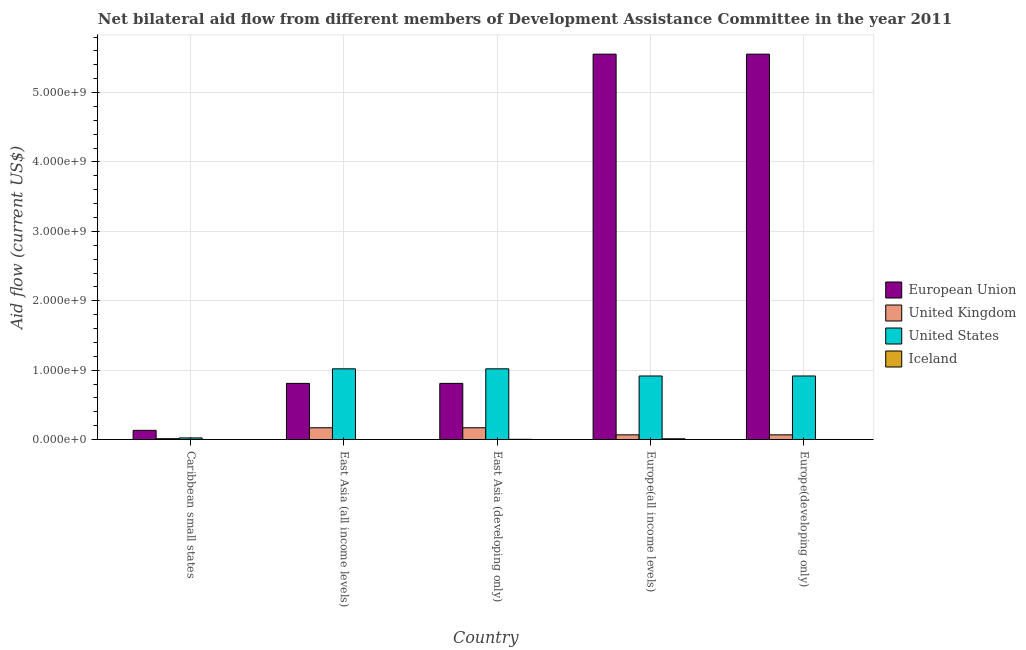How many different coloured bars are there?
Make the answer very short. 4. Are the number of bars per tick equal to the number of legend labels?
Offer a very short reply. Yes. How many bars are there on the 4th tick from the right?
Provide a succinct answer. 4. What is the label of the 3rd group of bars from the left?
Provide a succinct answer. East Asia (developing only). What is the amount of aid given by uk in Europe(developing only)?
Keep it short and to the point. 6.74e+07. Across all countries, what is the maximum amount of aid given by us?
Give a very brief answer. 1.02e+09. Across all countries, what is the minimum amount of aid given by iceland?
Your answer should be compact. 2.00e+04. In which country was the amount of aid given by us maximum?
Make the answer very short. East Asia (all income levels). In which country was the amount of aid given by uk minimum?
Keep it short and to the point. Caribbean small states. What is the total amount of aid given by iceland in the graph?
Offer a very short reply. 1.42e+07. What is the difference between the amount of aid given by iceland in Caribbean small states and that in East Asia (all income levels)?
Your response must be concise. 0. What is the difference between the amount of aid given by eu in East Asia (all income levels) and the amount of aid given by uk in Europe(developing only)?
Ensure brevity in your answer.  7.42e+08. What is the average amount of aid given by us per country?
Keep it short and to the point. 7.79e+08. What is the difference between the amount of aid given by eu and amount of aid given by us in Europe(all income levels)?
Ensure brevity in your answer.  4.64e+09. What is the ratio of the amount of aid given by eu in East Asia (all income levels) to that in Europe(developing only)?
Keep it short and to the point. 0.15. What is the difference between the highest and the second highest amount of aid given by eu?
Give a very brief answer. 0. What is the difference between the highest and the lowest amount of aid given by iceland?
Your response must be concise. 1.06e+07. In how many countries, is the amount of aid given by uk greater than the average amount of aid given by uk taken over all countries?
Keep it short and to the point. 2. Is it the case that in every country, the sum of the amount of aid given by iceland and amount of aid given by eu is greater than the sum of amount of aid given by uk and amount of aid given by us?
Ensure brevity in your answer.  Yes. Is it the case that in every country, the sum of the amount of aid given by eu and amount of aid given by uk is greater than the amount of aid given by us?
Your answer should be compact. No. What is the difference between two consecutive major ticks on the Y-axis?
Your answer should be very brief. 1.00e+09. Are the values on the major ticks of Y-axis written in scientific E-notation?
Offer a very short reply. Yes. Does the graph contain any zero values?
Keep it short and to the point. No. Where does the legend appear in the graph?
Give a very brief answer. Center right. How many legend labels are there?
Your answer should be very brief. 4. How are the legend labels stacked?
Make the answer very short. Vertical. What is the title of the graph?
Your response must be concise. Net bilateral aid flow from different members of Development Assistance Committee in the year 2011. What is the label or title of the X-axis?
Provide a succinct answer. Country. What is the Aid flow (current US$) in European Union in Caribbean small states?
Give a very brief answer. 1.32e+08. What is the Aid flow (current US$) in United Kingdom in Caribbean small states?
Give a very brief answer. 1.19e+07. What is the Aid flow (current US$) in United States in Caribbean small states?
Keep it short and to the point. 2.31e+07. What is the Aid flow (current US$) of European Union in East Asia (all income levels)?
Make the answer very short. 8.09e+08. What is the Aid flow (current US$) of United Kingdom in East Asia (all income levels)?
Your answer should be very brief. 1.69e+08. What is the Aid flow (current US$) in United States in East Asia (all income levels)?
Your response must be concise. 1.02e+09. What is the Aid flow (current US$) of Iceland in East Asia (all income levels)?
Your response must be concise. 2.00e+04. What is the Aid flow (current US$) in European Union in East Asia (developing only)?
Give a very brief answer. 8.09e+08. What is the Aid flow (current US$) of United Kingdom in East Asia (developing only)?
Your response must be concise. 1.69e+08. What is the Aid flow (current US$) in United States in East Asia (developing only)?
Make the answer very short. 1.02e+09. What is the Aid flow (current US$) in Iceland in East Asia (developing only)?
Your answer should be very brief. 2.81e+06. What is the Aid flow (current US$) in European Union in Europe(all income levels)?
Your answer should be very brief. 5.55e+09. What is the Aid flow (current US$) of United Kingdom in Europe(all income levels)?
Keep it short and to the point. 6.74e+07. What is the Aid flow (current US$) in United States in Europe(all income levels)?
Make the answer very short. 9.16e+08. What is the Aid flow (current US$) of Iceland in Europe(all income levels)?
Your answer should be compact. 1.06e+07. What is the Aid flow (current US$) in European Union in Europe(developing only)?
Your answer should be very brief. 5.55e+09. What is the Aid flow (current US$) in United Kingdom in Europe(developing only)?
Offer a terse response. 6.74e+07. What is the Aid flow (current US$) of United States in Europe(developing only)?
Provide a succinct answer. 9.16e+08. What is the Aid flow (current US$) of Iceland in Europe(developing only)?
Give a very brief answer. 6.80e+05. Across all countries, what is the maximum Aid flow (current US$) in European Union?
Give a very brief answer. 5.55e+09. Across all countries, what is the maximum Aid flow (current US$) of United Kingdom?
Ensure brevity in your answer.  1.69e+08. Across all countries, what is the maximum Aid flow (current US$) in United States?
Your answer should be compact. 1.02e+09. Across all countries, what is the maximum Aid flow (current US$) in Iceland?
Offer a very short reply. 1.06e+07. Across all countries, what is the minimum Aid flow (current US$) of European Union?
Offer a terse response. 1.32e+08. Across all countries, what is the minimum Aid flow (current US$) of United Kingdom?
Make the answer very short. 1.19e+07. Across all countries, what is the minimum Aid flow (current US$) of United States?
Ensure brevity in your answer.  2.31e+07. What is the total Aid flow (current US$) of European Union in the graph?
Offer a terse response. 1.29e+1. What is the total Aid flow (current US$) of United Kingdom in the graph?
Offer a very short reply. 4.86e+08. What is the total Aid flow (current US$) of United States in the graph?
Give a very brief answer. 3.89e+09. What is the total Aid flow (current US$) in Iceland in the graph?
Your response must be concise. 1.42e+07. What is the difference between the Aid flow (current US$) of European Union in Caribbean small states and that in East Asia (all income levels)?
Keep it short and to the point. -6.77e+08. What is the difference between the Aid flow (current US$) in United Kingdom in Caribbean small states and that in East Asia (all income levels)?
Make the answer very short. -1.58e+08. What is the difference between the Aid flow (current US$) of United States in Caribbean small states and that in East Asia (all income levels)?
Offer a terse response. -9.96e+08. What is the difference between the Aid flow (current US$) in Iceland in Caribbean small states and that in East Asia (all income levels)?
Keep it short and to the point. 0. What is the difference between the Aid flow (current US$) in European Union in Caribbean small states and that in East Asia (developing only)?
Your answer should be compact. -6.77e+08. What is the difference between the Aid flow (current US$) of United Kingdom in Caribbean small states and that in East Asia (developing only)?
Keep it short and to the point. -1.58e+08. What is the difference between the Aid flow (current US$) in United States in Caribbean small states and that in East Asia (developing only)?
Provide a succinct answer. -9.96e+08. What is the difference between the Aid flow (current US$) in Iceland in Caribbean small states and that in East Asia (developing only)?
Provide a short and direct response. -2.79e+06. What is the difference between the Aid flow (current US$) in European Union in Caribbean small states and that in Europe(all income levels)?
Offer a very short reply. -5.42e+09. What is the difference between the Aid flow (current US$) of United Kingdom in Caribbean small states and that in Europe(all income levels)?
Provide a succinct answer. -5.56e+07. What is the difference between the Aid flow (current US$) in United States in Caribbean small states and that in Europe(all income levels)?
Your answer should be compact. -8.93e+08. What is the difference between the Aid flow (current US$) in Iceland in Caribbean small states and that in Europe(all income levels)?
Ensure brevity in your answer.  -1.06e+07. What is the difference between the Aid flow (current US$) of European Union in Caribbean small states and that in Europe(developing only)?
Your response must be concise. -5.42e+09. What is the difference between the Aid flow (current US$) in United Kingdom in Caribbean small states and that in Europe(developing only)?
Offer a very short reply. -5.56e+07. What is the difference between the Aid flow (current US$) in United States in Caribbean small states and that in Europe(developing only)?
Ensure brevity in your answer.  -8.93e+08. What is the difference between the Aid flow (current US$) in Iceland in Caribbean small states and that in Europe(developing only)?
Keep it short and to the point. -6.60e+05. What is the difference between the Aid flow (current US$) of European Union in East Asia (all income levels) and that in East Asia (developing only)?
Offer a very short reply. 0. What is the difference between the Aid flow (current US$) in United Kingdom in East Asia (all income levels) and that in East Asia (developing only)?
Your response must be concise. 0. What is the difference between the Aid flow (current US$) in Iceland in East Asia (all income levels) and that in East Asia (developing only)?
Ensure brevity in your answer.  -2.79e+06. What is the difference between the Aid flow (current US$) in European Union in East Asia (all income levels) and that in Europe(all income levels)?
Make the answer very short. -4.75e+09. What is the difference between the Aid flow (current US$) in United Kingdom in East Asia (all income levels) and that in Europe(all income levels)?
Provide a short and direct response. 1.02e+08. What is the difference between the Aid flow (current US$) in United States in East Asia (all income levels) and that in Europe(all income levels)?
Ensure brevity in your answer.  1.03e+08. What is the difference between the Aid flow (current US$) in Iceland in East Asia (all income levels) and that in Europe(all income levels)?
Give a very brief answer. -1.06e+07. What is the difference between the Aid flow (current US$) in European Union in East Asia (all income levels) and that in Europe(developing only)?
Provide a short and direct response. -4.75e+09. What is the difference between the Aid flow (current US$) in United Kingdom in East Asia (all income levels) and that in Europe(developing only)?
Your response must be concise. 1.02e+08. What is the difference between the Aid flow (current US$) of United States in East Asia (all income levels) and that in Europe(developing only)?
Make the answer very short. 1.03e+08. What is the difference between the Aid flow (current US$) of Iceland in East Asia (all income levels) and that in Europe(developing only)?
Your answer should be compact. -6.60e+05. What is the difference between the Aid flow (current US$) of European Union in East Asia (developing only) and that in Europe(all income levels)?
Your answer should be very brief. -4.75e+09. What is the difference between the Aid flow (current US$) in United Kingdom in East Asia (developing only) and that in Europe(all income levels)?
Ensure brevity in your answer.  1.02e+08. What is the difference between the Aid flow (current US$) in United States in East Asia (developing only) and that in Europe(all income levels)?
Make the answer very short. 1.03e+08. What is the difference between the Aid flow (current US$) of Iceland in East Asia (developing only) and that in Europe(all income levels)?
Your answer should be compact. -7.84e+06. What is the difference between the Aid flow (current US$) of European Union in East Asia (developing only) and that in Europe(developing only)?
Provide a succinct answer. -4.75e+09. What is the difference between the Aid flow (current US$) in United Kingdom in East Asia (developing only) and that in Europe(developing only)?
Your answer should be very brief. 1.02e+08. What is the difference between the Aid flow (current US$) of United States in East Asia (developing only) and that in Europe(developing only)?
Offer a terse response. 1.03e+08. What is the difference between the Aid flow (current US$) in Iceland in East Asia (developing only) and that in Europe(developing only)?
Ensure brevity in your answer.  2.13e+06. What is the difference between the Aid flow (current US$) of Iceland in Europe(all income levels) and that in Europe(developing only)?
Provide a short and direct response. 9.97e+06. What is the difference between the Aid flow (current US$) of European Union in Caribbean small states and the Aid flow (current US$) of United Kingdom in East Asia (all income levels)?
Keep it short and to the point. -3.70e+07. What is the difference between the Aid flow (current US$) in European Union in Caribbean small states and the Aid flow (current US$) in United States in East Asia (all income levels)?
Provide a succinct answer. -8.87e+08. What is the difference between the Aid flow (current US$) of European Union in Caribbean small states and the Aid flow (current US$) of Iceland in East Asia (all income levels)?
Your answer should be very brief. 1.32e+08. What is the difference between the Aid flow (current US$) of United Kingdom in Caribbean small states and the Aid flow (current US$) of United States in East Asia (all income levels)?
Ensure brevity in your answer.  -1.01e+09. What is the difference between the Aid flow (current US$) in United Kingdom in Caribbean small states and the Aid flow (current US$) in Iceland in East Asia (all income levels)?
Your response must be concise. 1.19e+07. What is the difference between the Aid flow (current US$) in United States in Caribbean small states and the Aid flow (current US$) in Iceland in East Asia (all income levels)?
Ensure brevity in your answer.  2.31e+07. What is the difference between the Aid flow (current US$) of European Union in Caribbean small states and the Aid flow (current US$) of United Kingdom in East Asia (developing only)?
Your answer should be compact. -3.70e+07. What is the difference between the Aid flow (current US$) of European Union in Caribbean small states and the Aid flow (current US$) of United States in East Asia (developing only)?
Your answer should be very brief. -8.87e+08. What is the difference between the Aid flow (current US$) of European Union in Caribbean small states and the Aid flow (current US$) of Iceland in East Asia (developing only)?
Offer a terse response. 1.30e+08. What is the difference between the Aid flow (current US$) in United Kingdom in Caribbean small states and the Aid flow (current US$) in United States in East Asia (developing only)?
Keep it short and to the point. -1.01e+09. What is the difference between the Aid flow (current US$) in United Kingdom in Caribbean small states and the Aid flow (current US$) in Iceland in East Asia (developing only)?
Give a very brief answer. 9.07e+06. What is the difference between the Aid flow (current US$) of United States in Caribbean small states and the Aid flow (current US$) of Iceland in East Asia (developing only)?
Provide a succinct answer. 2.03e+07. What is the difference between the Aid flow (current US$) in European Union in Caribbean small states and the Aid flow (current US$) in United Kingdom in Europe(all income levels)?
Make the answer very short. 6.50e+07. What is the difference between the Aid flow (current US$) in European Union in Caribbean small states and the Aid flow (current US$) in United States in Europe(all income levels)?
Provide a short and direct response. -7.83e+08. What is the difference between the Aid flow (current US$) in European Union in Caribbean small states and the Aid flow (current US$) in Iceland in Europe(all income levels)?
Keep it short and to the point. 1.22e+08. What is the difference between the Aid flow (current US$) in United Kingdom in Caribbean small states and the Aid flow (current US$) in United States in Europe(all income levels)?
Your answer should be compact. -9.04e+08. What is the difference between the Aid flow (current US$) in United Kingdom in Caribbean small states and the Aid flow (current US$) in Iceland in Europe(all income levels)?
Offer a terse response. 1.23e+06. What is the difference between the Aid flow (current US$) in United States in Caribbean small states and the Aid flow (current US$) in Iceland in Europe(all income levels)?
Ensure brevity in your answer.  1.25e+07. What is the difference between the Aid flow (current US$) in European Union in Caribbean small states and the Aid flow (current US$) in United Kingdom in Europe(developing only)?
Make the answer very short. 6.50e+07. What is the difference between the Aid flow (current US$) of European Union in Caribbean small states and the Aid flow (current US$) of United States in Europe(developing only)?
Provide a succinct answer. -7.83e+08. What is the difference between the Aid flow (current US$) in European Union in Caribbean small states and the Aid flow (current US$) in Iceland in Europe(developing only)?
Ensure brevity in your answer.  1.32e+08. What is the difference between the Aid flow (current US$) of United Kingdom in Caribbean small states and the Aid flow (current US$) of United States in Europe(developing only)?
Offer a terse response. -9.04e+08. What is the difference between the Aid flow (current US$) in United Kingdom in Caribbean small states and the Aid flow (current US$) in Iceland in Europe(developing only)?
Your answer should be compact. 1.12e+07. What is the difference between the Aid flow (current US$) in United States in Caribbean small states and the Aid flow (current US$) in Iceland in Europe(developing only)?
Make the answer very short. 2.24e+07. What is the difference between the Aid flow (current US$) in European Union in East Asia (all income levels) and the Aid flow (current US$) in United Kingdom in East Asia (developing only)?
Provide a succinct answer. 6.40e+08. What is the difference between the Aid flow (current US$) of European Union in East Asia (all income levels) and the Aid flow (current US$) of United States in East Asia (developing only)?
Provide a succinct answer. -2.10e+08. What is the difference between the Aid flow (current US$) of European Union in East Asia (all income levels) and the Aid flow (current US$) of Iceland in East Asia (developing only)?
Give a very brief answer. 8.06e+08. What is the difference between the Aid flow (current US$) in United Kingdom in East Asia (all income levels) and the Aid flow (current US$) in United States in East Asia (developing only)?
Provide a succinct answer. -8.50e+08. What is the difference between the Aid flow (current US$) of United Kingdom in East Asia (all income levels) and the Aid flow (current US$) of Iceland in East Asia (developing only)?
Offer a terse response. 1.67e+08. What is the difference between the Aid flow (current US$) of United States in East Asia (all income levels) and the Aid flow (current US$) of Iceland in East Asia (developing only)?
Ensure brevity in your answer.  1.02e+09. What is the difference between the Aid flow (current US$) of European Union in East Asia (all income levels) and the Aid flow (current US$) of United Kingdom in Europe(all income levels)?
Provide a succinct answer. 7.42e+08. What is the difference between the Aid flow (current US$) of European Union in East Asia (all income levels) and the Aid flow (current US$) of United States in Europe(all income levels)?
Make the answer very short. -1.07e+08. What is the difference between the Aid flow (current US$) of European Union in East Asia (all income levels) and the Aid flow (current US$) of Iceland in Europe(all income levels)?
Make the answer very short. 7.99e+08. What is the difference between the Aid flow (current US$) in United Kingdom in East Asia (all income levels) and the Aid flow (current US$) in United States in Europe(all income levels)?
Keep it short and to the point. -7.46e+08. What is the difference between the Aid flow (current US$) of United Kingdom in East Asia (all income levels) and the Aid flow (current US$) of Iceland in Europe(all income levels)?
Provide a short and direct response. 1.59e+08. What is the difference between the Aid flow (current US$) in United States in East Asia (all income levels) and the Aid flow (current US$) in Iceland in Europe(all income levels)?
Your answer should be compact. 1.01e+09. What is the difference between the Aid flow (current US$) in European Union in East Asia (all income levels) and the Aid flow (current US$) in United Kingdom in Europe(developing only)?
Keep it short and to the point. 7.42e+08. What is the difference between the Aid flow (current US$) of European Union in East Asia (all income levels) and the Aid flow (current US$) of United States in Europe(developing only)?
Provide a short and direct response. -1.07e+08. What is the difference between the Aid flow (current US$) in European Union in East Asia (all income levels) and the Aid flow (current US$) in Iceland in Europe(developing only)?
Your answer should be compact. 8.09e+08. What is the difference between the Aid flow (current US$) of United Kingdom in East Asia (all income levels) and the Aid flow (current US$) of United States in Europe(developing only)?
Your response must be concise. -7.46e+08. What is the difference between the Aid flow (current US$) of United Kingdom in East Asia (all income levels) and the Aid flow (current US$) of Iceland in Europe(developing only)?
Make the answer very short. 1.69e+08. What is the difference between the Aid flow (current US$) in United States in East Asia (all income levels) and the Aid flow (current US$) in Iceland in Europe(developing only)?
Make the answer very short. 1.02e+09. What is the difference between the Aid flow (current US$) in European Union in East Asia (developing only) and the Aid flow (current US$) in United Kingdom in Europe(all income levels)?
Your response must be concise. 7.42e+08. What is the difference between the Aid flow (current US$) of European Union in East Asia (developing only) and the Aid flow (current US$) of United States in Europe(all income levels)?
Make the answer very short. -1.07e+08. What is the difference between the Aid flow (current US$) in European Union in East Asia (developing only) and the Aid flow (current US$) in Iceland in Europe(all income levels)?
Your response must be concise. 7.99e+08. What is the difference between the Aid flow (current US$) in United Kingdom in East Asia (developing only) and the Aid flow (current US$) in United States in Europe(all income levels)?
Make the answer very short. -7.46e+08. What is the difference between the Aid flow (current US$) of United Kingdom in East Asia (developing only) and the Aid flow (current US$) of Iceland in Europe(all income levels)?
Make the answer very short. 1.59e+08. What is the difference between the Aid flow (current US$) of United States in East Asia (developing only) and the Aid flow (current US$) of Iceland in Europe(all income levels)?
Offer a very short reply. 1.01e+09. What is the difference between the Aid flow (current US$) of European Union in East Asia (developing only) and the Aid flow (current US$) of United Kingdom in Europe(developing only)?
Your answer should be compact. 7.42e+08. What is the difference between the Aid flow (current US$) of European Union in East Asia (developing only) and the Aid flow (current US$) of United States in Europe(developing only)?
Offer a very short reply. -1.07e+08. What is the difference between the Aid flow (current US$) in European Union in East Asia (developing only) and the Aid flow (current US$) in Iceland in Europe(developing only)?
Give a very brief answer. 8.09e+08. What is the difference between the Aid flow (current US$) of United Kingdom in East Asia (developing only) and the Aid flow (current US$) of United States in Europe(developing only)?
Give a very brief answer. -7.46e+08. What is the difference between the Aid flow (current US$) in United Kingdom in East Asia (developing only) and the Aid flow (current US$) in Iceland in Europe(developing only)?
Offer a very short reply. 1.69e+08. What is the difference between the Aid flow (current US$) of United States in East Asia (developing only) and the Aid flow (current US$) of Iceland in Europe(developing only)?
Offer a very short reply. 1.02e+09. What is the difference between the Aid flow (current US$) of European Union in Europe(all income levels) and the Aid flow (current US$) of United Kingdom in Europe(developing only)?
Provide a short and direct response. 5.49e+09. What is the difference between the Aid flow (current US$) of European Union in Europe(all income levels) and the Aid flow (current US$) of United States in Europe(developing only)?
Provide a short and direct response. 4.64e+09. What is the difference between the Aid flow (current US$) of European Union in Europe(all income levels) and the Aid flow (current US$) of Iceland in Europe(developing only)?
Make the answer very short. 5.55e+09. What is the difference between the Aid flow (current US$) of United Kingdom in Europe(all income levels) and the Aid flow (current US$) of United States in Europe(developing only)?
Your response must be concise. -8.48e+08. What is the difference between the Aid flow (current US$) of United Kingdom in Europe(all income levels) and the Aid flow (current US$) of Iceland in Europe(developing only)?
Your response must be concise. 6.68e+07. What is the difference between the Aid flow (current US$) of United States in Europe(all income levels) and the Aid flow (current US$) of Iceland in Europe(developing only)?
Provide a short and direct response. 9.15e+08. What is the average Aid flow (current US$) in European Union per country?
Provide a succinct answer. 2.57e+09. What is the average Aid flow (current US$) of United Kingdom per country?
Offer a very short reply. 9.71e+07. What is the average Aid flow (current US$) in United States per country?
Your answer should be compact. 7.79e+08. What is the average Aid flow (current US$) of Iceland per country?
Offer a very short reply. 2.84e+06. What is the difference between the Aid flow (current US$) of European Union and Aid flow (current US$) of United Kingdom in Caribbean small states?
Offer a very short reply. 1.21e+08. What is the difference between the Aid flow (current US$) of European Union and Aid flow (current US$) of United States in Caribbean small states?
Offer a terse response. 1.09e+08. What is the difference between the Aid flow (current US$) of European Union and Aid flow (current US$) of Iceland in Caribbean small states?
Provide a succinct answer. 1.32e+08. What is the difference between the Aid flow (current US$) in United Kingdom and Aid flow (current US$) in United States in Caribbean small states?
Keep it short and to the point. -1.12e+07. What is the difference between the Aid flow (current US$) of United Kingdom and Aid flow (current US$) of Iceland in Caribbean small states?
Provide a succinct answer. 1.19e+07. What is the difference between the Aid flow (current US$) in United States and Aid flow (current US$) in Iceland in Caribbean small states?
Provide a succinct answer. 2.31e+07. What is the difference between the Aid flow (current US$) of European Union and Aid flow (current US$) of United Kingdom in East Asia (all income levels)?
Keep it short and to the point. 6.40e+08. What is the difference between the Aid flow (current US$) in European Union and Aid flow (current US$) in United States in East Asia (all income levels)?
Your answer should be compact. -2.10e+08. What is the difference between the Aid flow (current US$) in European Union and Aid flow (current US$) in Iceland in East Asia (all income levels)?
Make the answer very short. 8.09e+08. What is the difference between the Aid flow (current US$) of United Kingdom and Aid flow (current US$) of United States in East Asia (all income levels)?
Offer a terse response. -8.50e+08. What is the difference between the Aid flow (current US$) in United Kingdom and Aid flow (current US$) in Iceland in East Asia (all income levels)?
Provide a short and direct response. 1.69e+08. What is the difference between the Aid flow (current US$) in United States and Aid flow (current US$) in Iceland in East Asia (all income levels)?
Offer a very short reply. 1.02e+09. What is the difference between the Aid flow (current US$) in European Union and Aid flow (current US$) in United Kingdom in East Asia (developing only)?
Your answer should be very brief. 6.40e+08. What is the difference between the Aid flow (current US$) of European Union and Aid flow (current US$) of United States in East Asia (developing only)?
Your answer should be very brief. -2.10e+08. What is the difference between the Aid flow (current US$) of European Union and Aid flow (current US$) of Iceland in East Asia (developing only)?
Keep it short and to the point. 8.06e+08. What is the difference between the Aid flow (current US$) of United Kingdom and Aid flow (current US$) of United States in East Asia (developing only)?
Provide a succinct answer. -8.50e+08. What is the difference between the Aid flow (current US$) in United Kingdom and Aid flow (current US$) in Iceland in East Asia (developing only)?
Give a very brief answer. 1.67e+08. What is the difference between the Aid flow (current US$) of United States and Aid flow (current US$) of Iceland in East Asia (developing only)?
Keep it short and to the point. 1.02e+09. What is the difference between the Aid flow (current US$) of European Union and Aid flow (current US$) of United Kingdom in Europe(all income levels)?
Ensure brevity in your answer.  5.49e+09. What is the difference between the Aid flow (current US$) of European Union and Aid flow (current US$) of United States in Europe(all income levels)?
Provide a short and direct response. 4.64e+09. What is the difference between the Aid flow (current US$) of European Union and Aid flow (current US$) of Iceland in Europe(all income levels)?
Provide a short and direct response. 5.54e+09. What is the difference between the Aid flow (current US$) in United Kingdom and Aid flow (current US$) in United States in Europe(all income levels)?
Your answer should be very brief. -8.48e+08. What is the difference between the Aid flow (current US$) in United Kingdom and Aid flow (current US$) in Iceland in Europe(all income levels)?
Your response must be concise. 5.68e+07. What is the difference between the Aid flow (current US$) in United States and Aid flow (current US$) in Iceland in Europe(all income levels)?
Your answer should be very brief. 9.05e+08. What is the difference between the Aid flow (current US$) of European Union and Aid flow (current US$) of United Kingdom in Europe(developing only)?
Ensure brevity in your answer.  5.49e+09. What is the difference between the Aid flow (current US$) in European Union and Aid flow (current US$) in United States in Europe(developing only)?
Keep it short and to the point. 4.64e+09. What is the difference between the Aid flow (current US$) in European Union and Aid flow (current US$) in Iceland in Europe(developing only)?
Offer a very short reply. 5.55e+09. What is the difference between the Aid flow (current US$) in United Kingdom and Aid flow (current US$) in United States in Europe(developing only)?
Ensure brevity in your answer.  -8.48e+08. What is the difference between the Aid flow (current US$) of United Kingdom and Aid flow (current US$) of Iceland in Europe(developing only)?
Ensure brevity in your answer.  6.68e+07. What is the difference between the Aid flow (current US$) in United States and Aid flow (current US$) in Iceland in Europe(developing only)?
Give a very brief answer. 9.15e+08. What is the ratio of the Aid flow (current US$) of European Union in Caribbean small states to that in East Asia (all income levels)?
Offer a very short reply. 0.16. What is the ratio of the Aid flow (current US$) in United Kingdom in Caribbean small states to that in East Asia (all income levels)?
Ensure brevity in your answer.  0.07. What is the ratio of the Aid flow (current US$) in United States in Caribbean small states to that in East Asia (all income levels)?
Provide a short and direct response. 0.02. What is the ratio of the Aid flow (current US$) in European Union in Caribbean small states to that in East Asia (developing only)?
Provide a short and direct response. 0.16. What is the ratio of the Aid flow (current US$) of United Kingdom in Caribbean small states to that in East Asia (developing only)?
Give a very brief answer. 0.07. What is the ratio of the Aid flow (current US$) of United States in Caribbean small states to that in East Asia (developing only)?
Your answer should be very brief. 0.02. What is the ratio of the Aid flow (current US$) of Iceland in Caribbean small states to that in East Asia (developing only)?
Ensure brevity in your answer.  0.01. What is the ratio of the Aid flow (current US$) in European Union in Caribbean small states to that in Europe(all income levels)?
Offer a very short reply. 0.02. What is the ratio of the Aid flow (current US$) in United Kingdom in Caribbean small states to that in Europe(all income levels)?
Your answer should be compact. 0.18. What is the ratio of the Aid flow (current US$) of United States in Caribbean small states to that in Europe(all income levels)?
Ensure brevity in your answer.  0.03. What is the ratio of the Aid flow (current US$) in Iceland in Caribbean small states to that in Europe(all income levels)?
Provide a succinct answer. 0. What is the ratio of the Aid flow (current US$) of European Union in Caribbean small states to that in Europe(developing only)?
Offer a terse response. 0.02. What is the ratio of the Aid flow (current US$) in United Kingdom in Caribbean small states to that in Europe(developing only)?
Offer a very short reply. 0.18. What is the ratio of the Aid flow (current US$) in United States in Caribbean small states to that in Europe(developing only)?
Offer a very short reply. 0.03. What is the ratio of the Aid flow (current US$) of Iceland in Caribbean small states to that in Europe(developing only)?
Make the answer very short. 0.03. What is the ratio of the Aid flow (current US$) of United Kingdom in East Asia (all income levels) to that in East Asia (developing only)?
Offer a very short reply. 1. What is the ratio of the Aid flow (current US$) of Iceland in East Asia (all income levels) to that in East Asia (developing only)?
Make the answer very short. 0.01. What is the ratio of the Aid flow (current US$) in European Union in East Asia (all income levels) to that in Europe(all income levels)?
Make the answer very short. 0.15. What is the ratio of the Aid flow (current US$) in United Kingdom in East Asia (all income levels) to that in Europe(all income levels)?
Keep it short and to the point. 2.51. What is the ratio of the Aid flow (current US$) of United States in East Asia (all income levels) to that in Europe(all income levels)?
Provide a short and direct response. 1.11. What is the ratio of the Aid flow (current US$) in Iceland in East Asia (all income levels) to that in Europe(all income levels)?
Offer a terse response. 0. What is the ratio of the Aid flow (current US$) of European Union in East Asia (all income levels) to that in Europe(developing only)?
Your response must be concise. 0.15. What is the ratio of the Aid flow (current US$) of United Kingdom in East Asia (all income levels) to that in Europe(developing only)?
Provide a short and direct response. 2.51. What is the ratio of the Aid flow (current US$) in United States in East Asia (all income levels) to that in Europe(developing only)?
Keep it short and to the point. 1.11. What is the ratio of the Aid flow (current US$) of Iceland in East Asia (all income levels) to that in Europe(developing only)?
Provide a succinct answer. 0.03. What is the ratio of the Aid flow (current US$) in European Union in East Asia (developing only) to that in Europe(all income levels)?
Keep it short and to the point. 0.15. What is the ratio of the Aid flow (current US$) in United Kingdom in East Asia (developing only) to that in Europe(all income levels)?
Your answer should be very brief. 2.51. What is the ratio of the Aid flow (current US$) in United States in East Asia (developing only) to that in Europe(all income levels)?
Keep it short and to the point. 1.11. What is the ratio of the Aid flow (current US$) in Iceland in East Asia (developing only) to that in Europe(all income levels)?
Offer a very short reply. 0.26. What is the ratio of the Aid flow (current US$) of European Union in East Asia (developing only) to that in Europe(developing only)?
Keep it short and to the point. 0.15. What is the ratio of the Aid flow (current US$) of United Kingdom in East Asia (developing only) to that in Europe(developing only)?
Your answer should be compact. 2.51. What is the ratio of the Aid flow (current US$) of United States in East Asia (developing only) to that in Europe(developing only)?
Ensure brevity in your answer.  1.11. What is the ratio of the Aid flow (current US$) in Iceland in East Asia (developing only) to that in Europe(developing only)?
Your answer should be very brief. 4.13. What is the ratio of the Aid flow (current US$) in Iceland in Europe(all income levels) to that in Europe(developing only)?
Your response must be concise. 15.66. What is the difference between the highest and the second highest Aid flow (current US$) of European Union?
Your answer should be compact. 0. What is the difference between the highest and the second highest Aid flow (current US$) of United Kingdom?
Give a very brief answer. 0. What is the difference between the highest and the second highest Aid flow (current US$) in Iceland?
Your answer should be compact. 7.84e+06. What is the difference between the highest and the lowest Aid flow (current US$) in European Union?
Give a very brief answer. 5.42e+09. What is the difference between the highest and the lowest Aid flow (current US$) of United Kingdom?
Offer a terse response. 1.58e+08. What is the difference between the highest and the lowest Aid flow (current US$) of United States?
Ensure brevity in your answer.  9.96e+08. What is the difference between the highest and the lowest Aid flow (current US$) of Iceland?
Ensure brevity in your answer.  1.06e+07. 